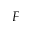Convert formula to latex. <formula><loc_0><loc_0><loc_500><loc_500>F</formula> 